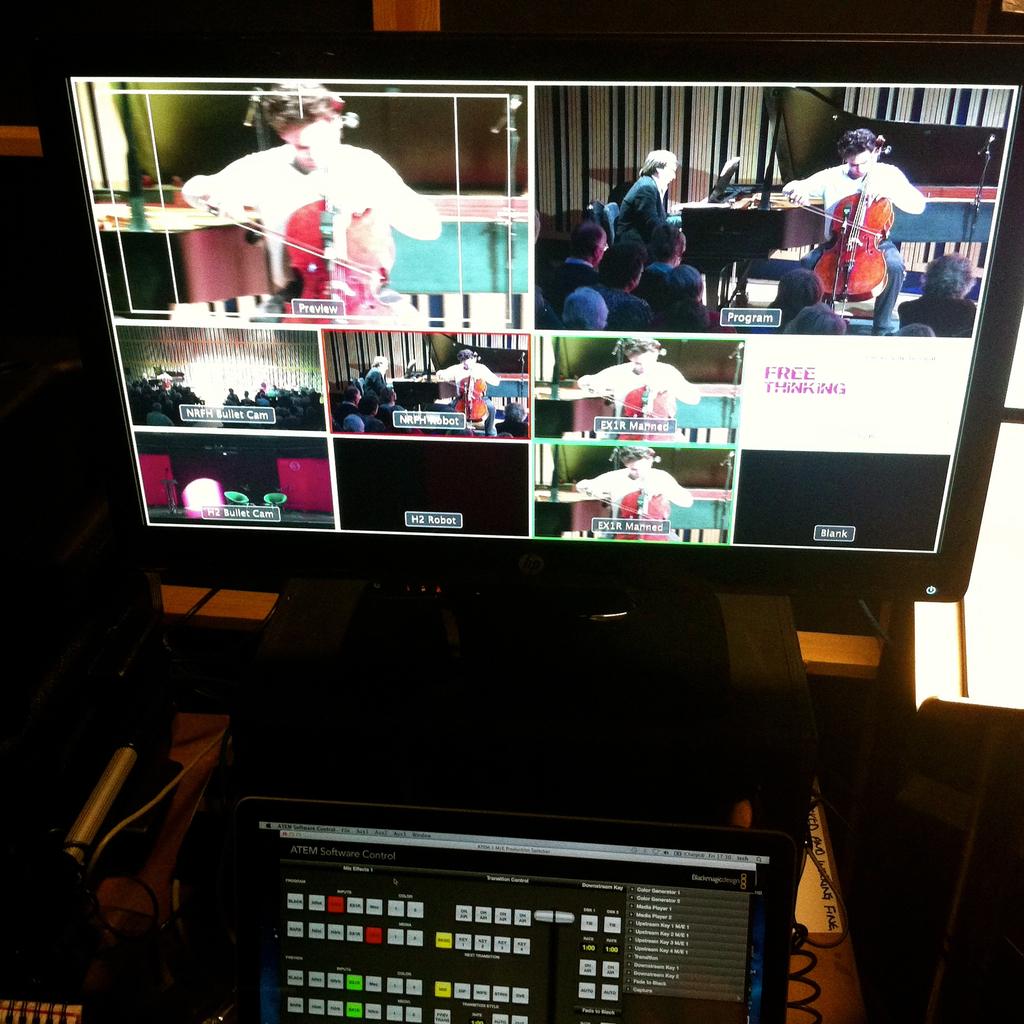What kind thinking on the screen?
Give a very brief answer. Free. What is the shown in the top left image on the monitor?
Ensure brevity in your answer.  Preview. 